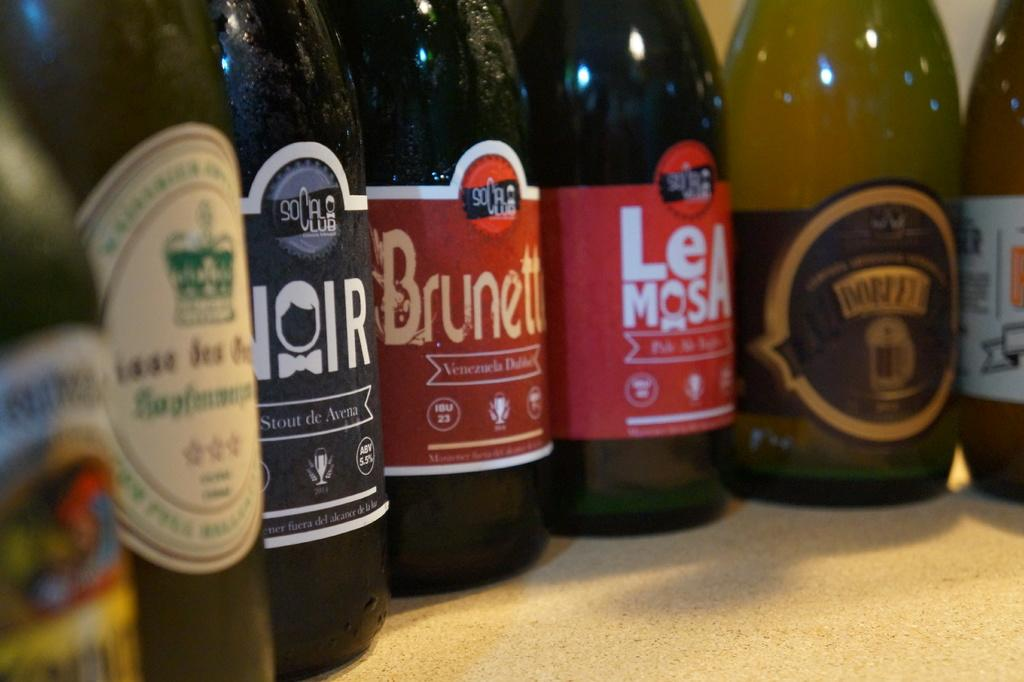Provide a one-sentence caption for the provided image. Bottles of beer with different names and labels, at least two are from socalclub.,. 